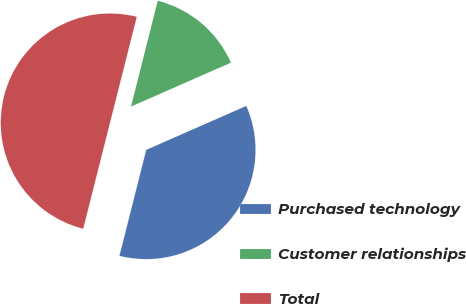<chart> <loc_0><loc_0><loc_500><loc_500><pie_chart><fcel>Purchased technology<fcel>Customer relationships<fcel>Total<nl><fcel>35.53%<fcel>14.47%<fcel>50.0%<nl></chart> 